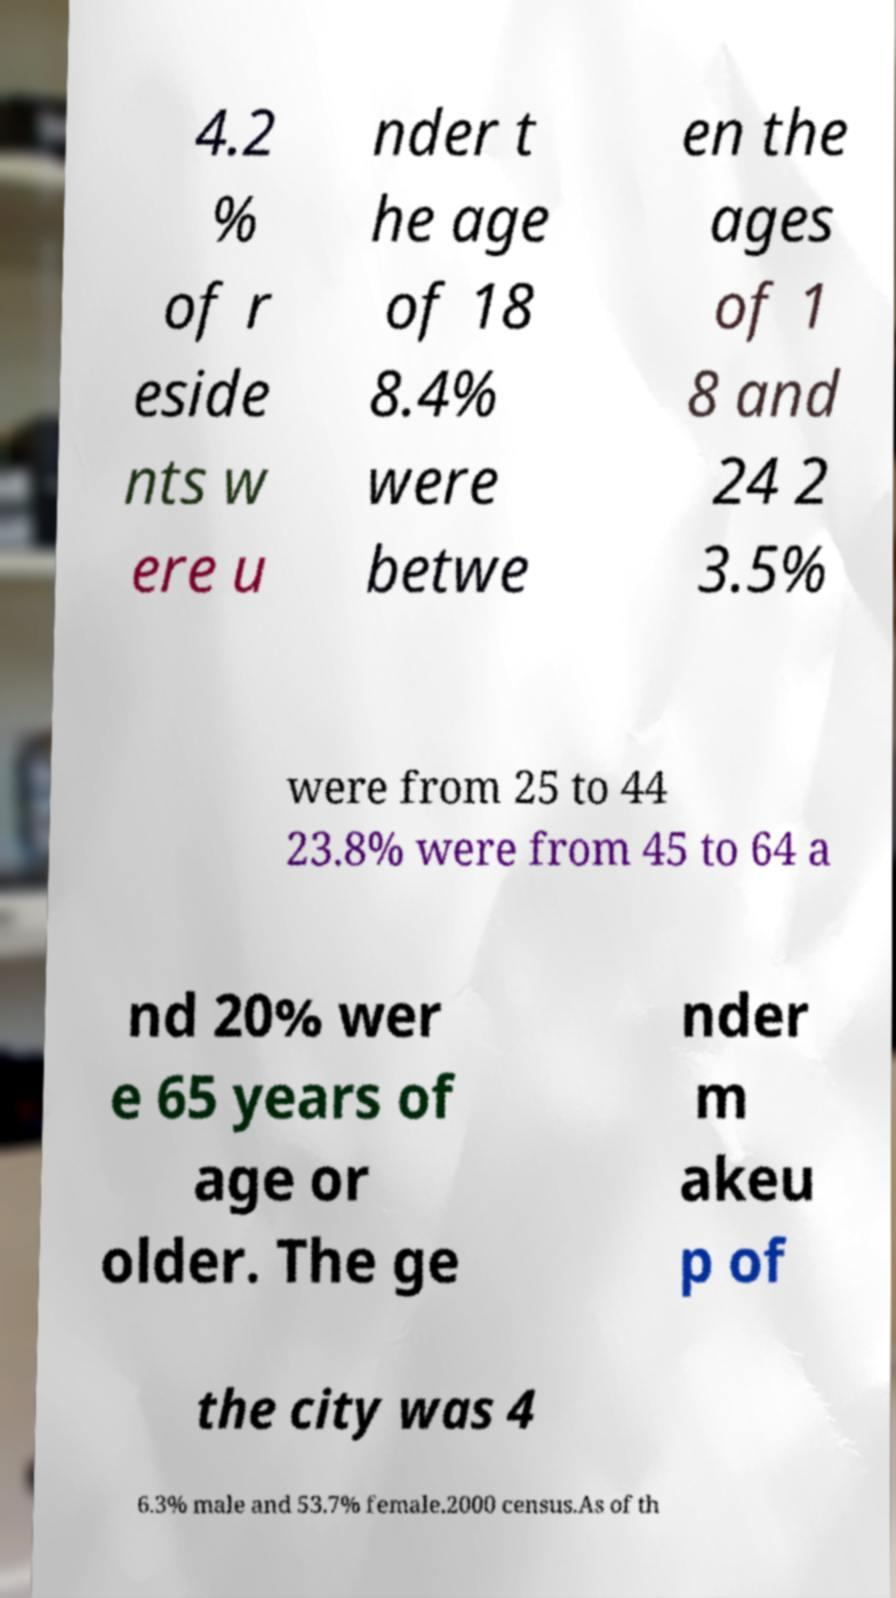For documentation purposes, I need the text within this image transcribed. Could you provide that? 4.2 % of r eside nts w ere u nder t he age of 18 8.4% were betwe en the ages of 1 8 and 24 2 3.5% were from 25 to 44 23.8% were from 45 to 64 a nd 20% wer e 65 years of age or older. The ge nder m akeu p of the city was 4 6.3% male and 53.7% female.2000 census.As of th 